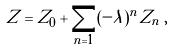<formula> <loc_0><loc_0><loc_500><loc_500>Z = Z _ { 0 } + \sum _ { n = 1 } ( - \lambda ) ^ { n } Z _ { n } \, ,</formula> 